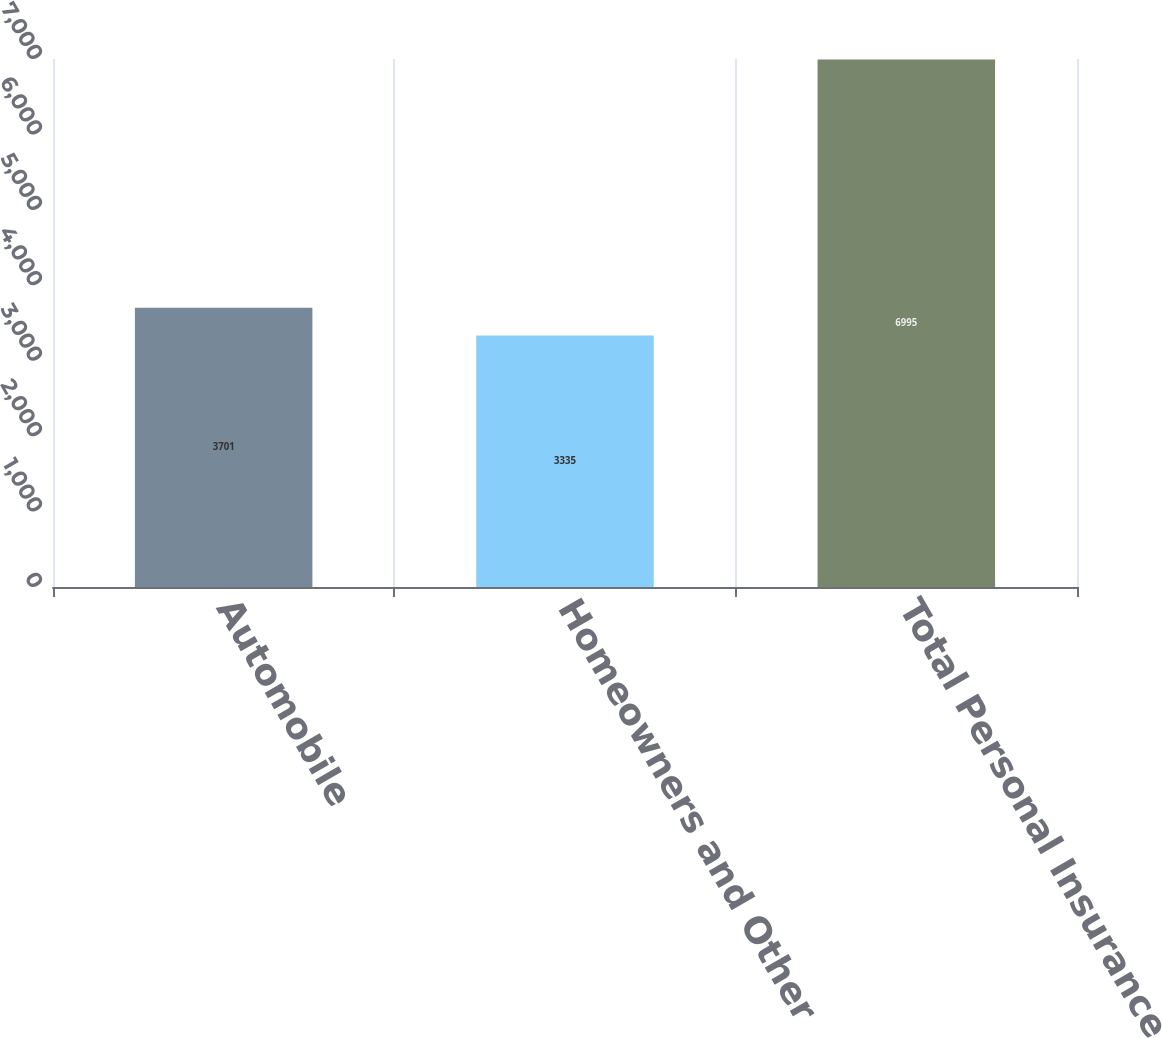<chart> <loc_0><loc_0><loc_500><loc_500><bar_chart><fcel>Automobile<fcel>Homeowners and Other<fcel>Total Personal Insurance<nl><fcel>3701<fcel>3335<fcel>6995<nl></chart> 